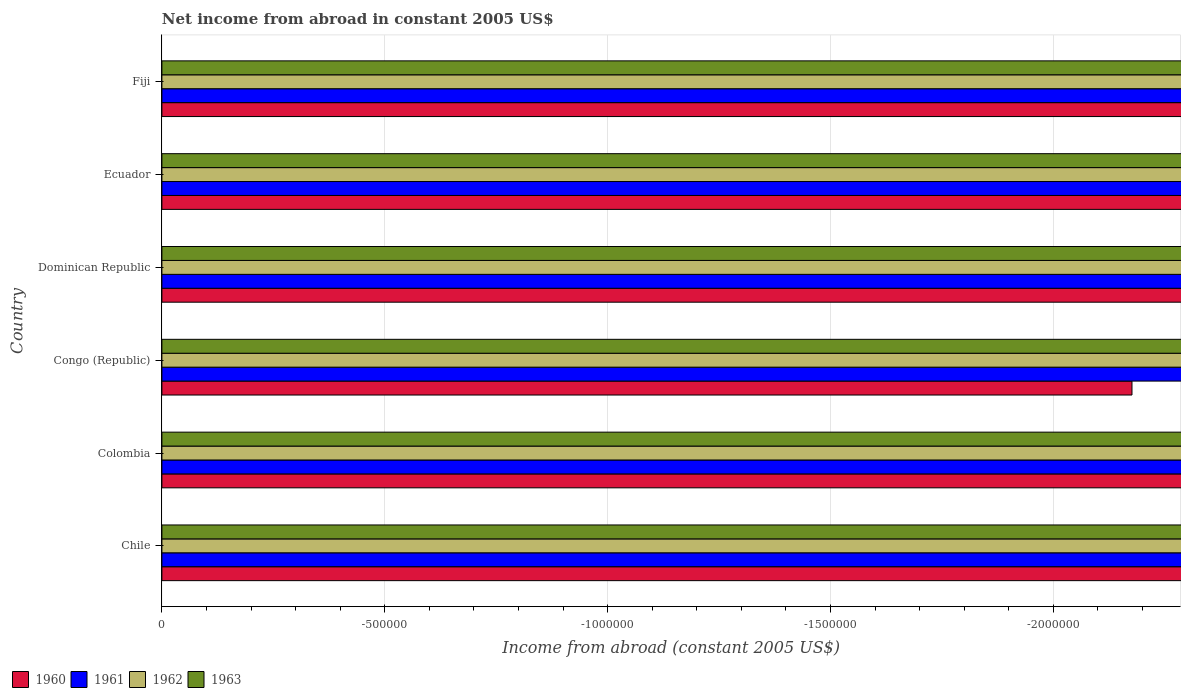How many different coloured bars are there?
Offer a terse response. 0. How many bars are there on the 4th tick from the bottom?
Provide a succinct answer. 0. What is the label of the 3rd group of bars from the top?
Provide a succinct answer. Dominican Republic. In how many cases, is the number of bars for a given country not equal to the number of legend labels?
Provide a succinct answer. 6. What is the net income from abroad in 1960 in Dominican Republic?
Offer a very short reply. 0. Across all countries, what is the minimum net income from abroad in 1963?
Offer a very short reply. 0. What is the difference between the net income from abroad in 1962 in Congo (Republic) and the net income from abroad in 1960 in Fiji?
Give a very brief answer. 0. In how many countries, is the net income from abroad in 1963 greater than -400000 US$?
Offer a very short reply. 0. In how many countries, is the net income from abroad in 1961 greater than the average net income from abroad in 1961 taken over all countries?
Make the answer very short. 0. How many countries are there in the graph?
Make the answer very short. 6. Where does the legend appear in the graph?
Ensure brevity in your answer.  Bottom left. What is the title of the graph?
Your response must be concise. Net income from abroad in constant 2005 US$. What is the label or title of the X-axis?
Provide a short and direct response. Income from abroad (constant 2005 US$). What is the Income from abroad (constant 2005 US$) of 1962 in Chile?
Keep it short and to the point. 0. What is the Income from abroad (constant 2005 US$) of 1963 in Chile?
Give a very brief answer. 0. What is the Income from abroad (constant 2005 US$) in 1961 in Colombia?
Offer a very short reply. 0. What is the Income from abroad (constant 2005 US$) of 1960 in Congo (Republic)?
Your response must be concise. 0. What is the Income from abroad (constant 2005 US$) of 1962 in Congo (Republic)?
Offer a terse response. 0. What is the Income from abroad (constant 2005 US$) of 1963 in Congo (Republic)?
Keep it short and to the point. 0. What is the Income from abroad (constant 2005 US$) of 1960 in Dominican Republic?
Your answer should be compact. 0. What is the Income from abroad (constant 2005 US$) in 1961 in Dominican Republic?
Your response must be concise. 0. What is the Income from abroad (constant 2005 US$) in 1961 in Ecuador?
Keep it short and to the point. 0. What is the Income from abroad (constant 2005 US$) in 1963 in Ecuador?
Make the answer very short. 0. What is the Income from abroad (constant 2005 US$) of 1960 in Fiji?
Ensure brevity in your answer.  0. What is the Income from abroad (constant 2005 US$) of 1962 in Fiji?
Offer a very short reply. 0. What is the Income from abroad (constant 2005 US$) of 1963 in Fiji?
Ensure brevity in your answer.  0. What is the total Income from abroad (constant 2005 US$) of 1960 in the graph?
Provide a succinct answer. 0. What is the total Income from abroad (constant 2005 US$) of 1961 in the graph?
Ensure brevity in your answer.  0. What is the total Income from abroad (constant 2005 US$) of 1963 in the graph?
Offer a terse response. 0. What is the average Income from abroad (constant 2005 US$) in 1960 per country?
Your answer should be very brief. 0. What is the average Income from abroad (constant 2005 US$) in 1962 per country?
Ensure brevity in your answer.  0. What is the average Income from abroad (constant 2005 US$) of 1963 per country?
Offer a very short reply. 0. 